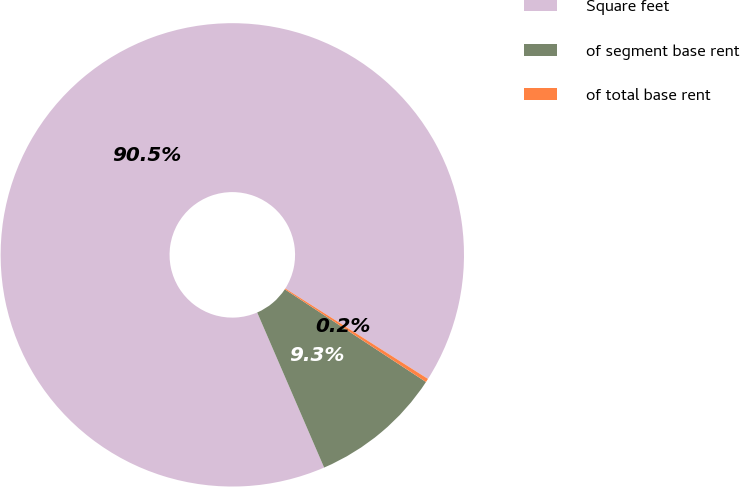Convert chart. <chart><loc_0><loc_0><loc_500><loc_500><pie_chart><fcel>Square feet<fcel>of segment base rent<fcel>of total base rent<nl><fcel>90.48%<fcel>9.27%<fcel>0.25%<nl></chart> 